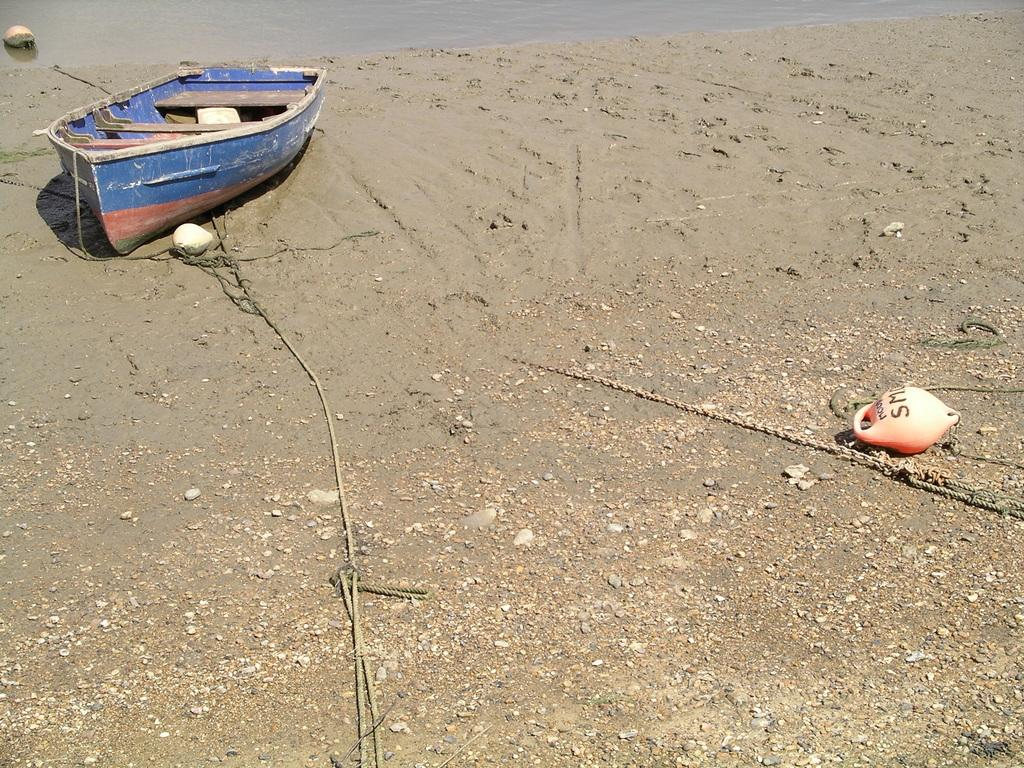<image>
Create a compact narrative representing the image presented. Boat next to an orange object which says "SM" on it. 